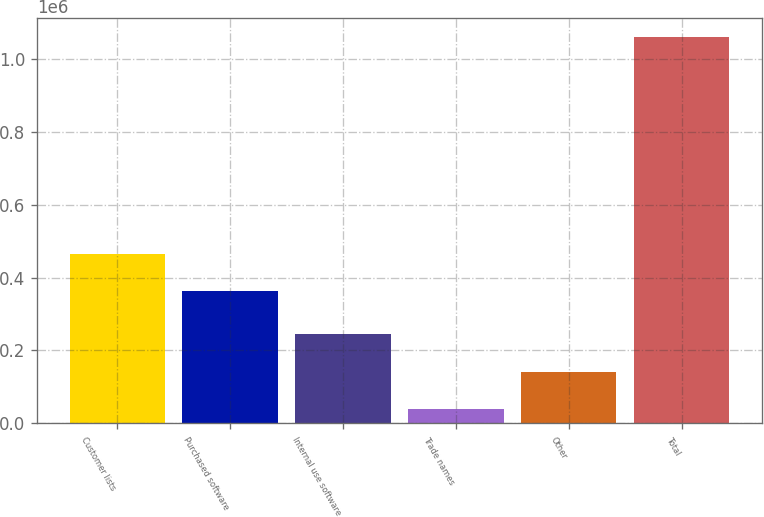Convert chart to OTSL. <chart><loc_0><loc_0><loc_500><loc_500><bar_chart><fcel>Customer lists<fcel>Purchased software<fcel>Internal use software<fcel>Trade names<fcel>Other<fcel>Total<nl><fcel>465909<fcel>361964<fcel>243885<fcel>40025<fcel>141955<fcel>1.05932e+06<nl></chart> 